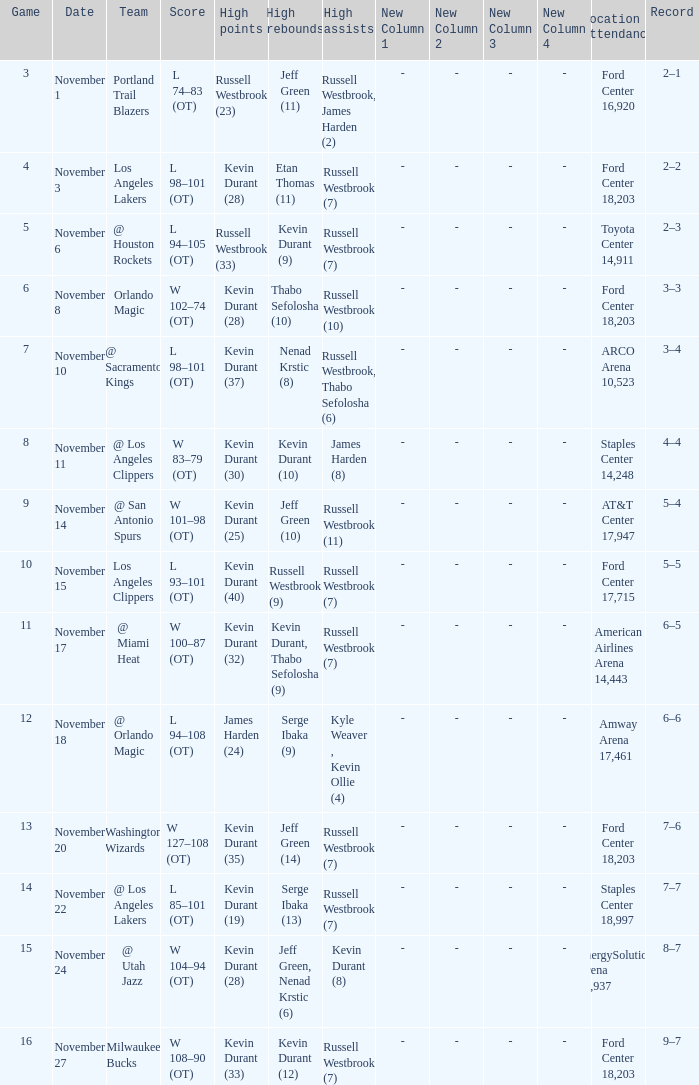What was the record in the game in which Jeff Green (14) did the most high rebounds? 7–6. 